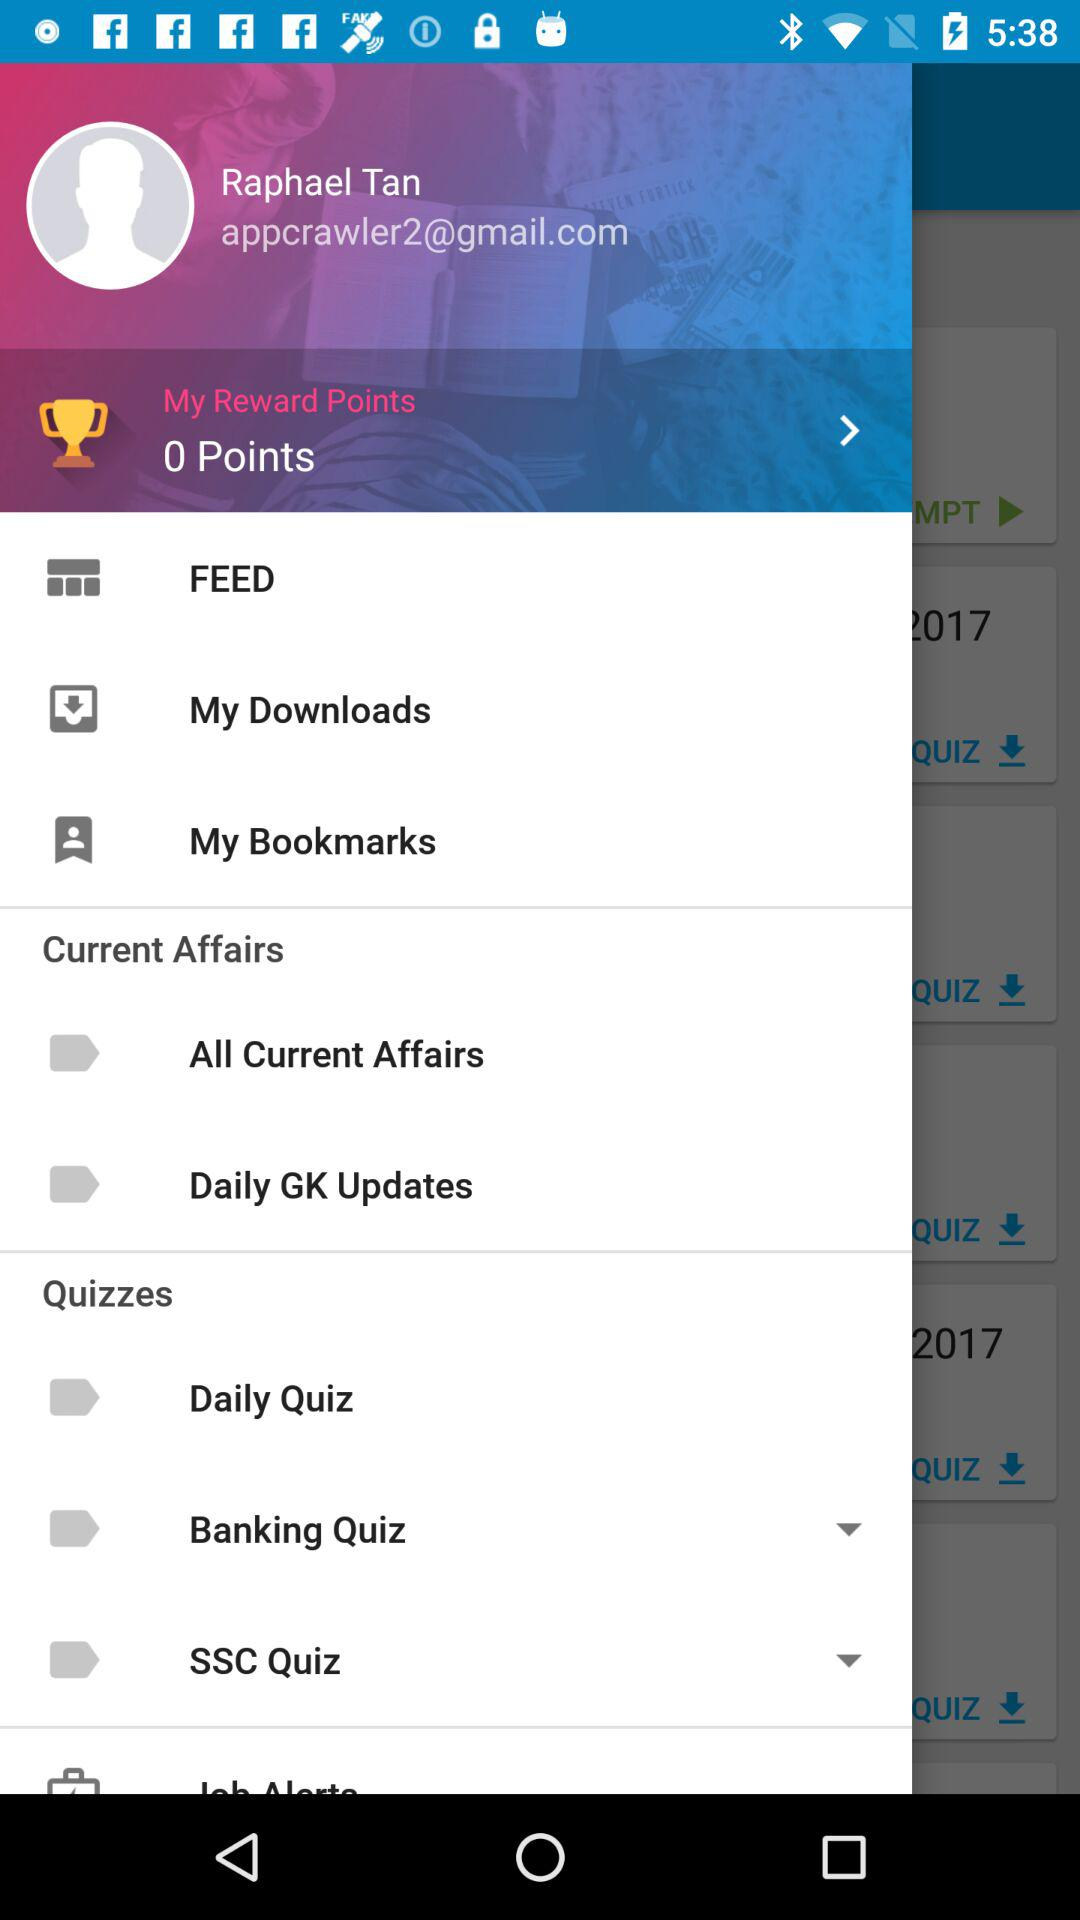What is the name of the user? The name of the user is Raphael Tan. 